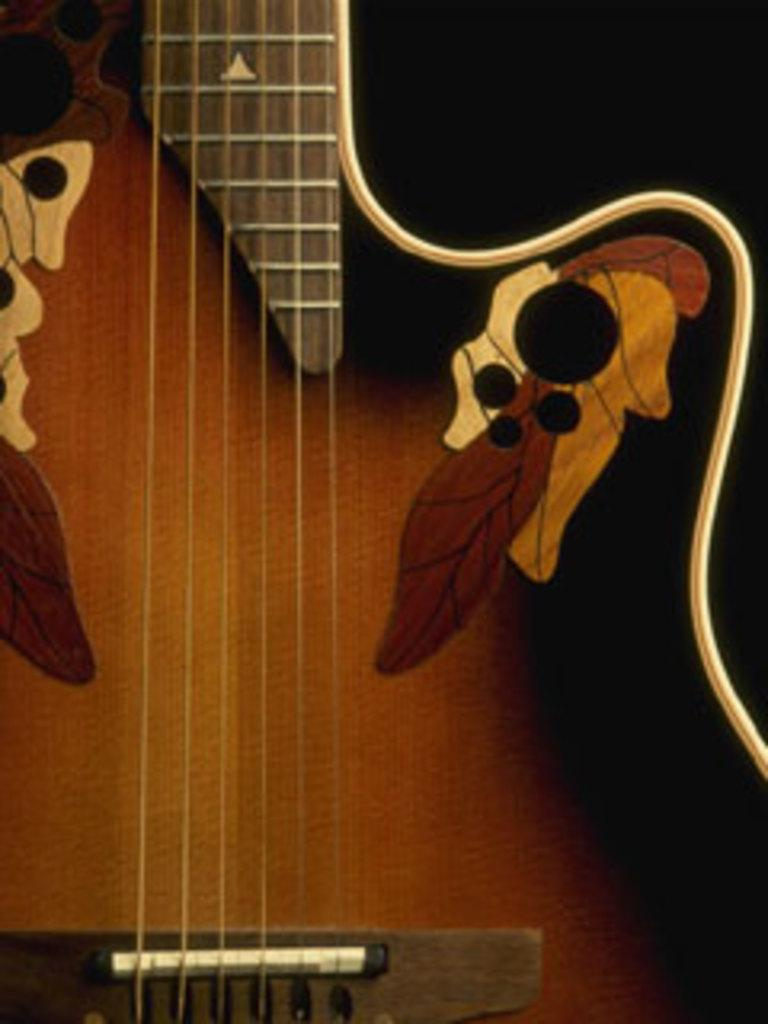What musical instrument is present in the image? There is a guitar in the image. What is the color of the guitar? The guitar is brown in color. How many houses can be seen in the image? There are no houses present in the image; it features a guitar. What type of animal is playing the guitar in the image? There is no animal, such as a donkey, present in the image; it features a guitar without any indication of who or what might be playing it. 